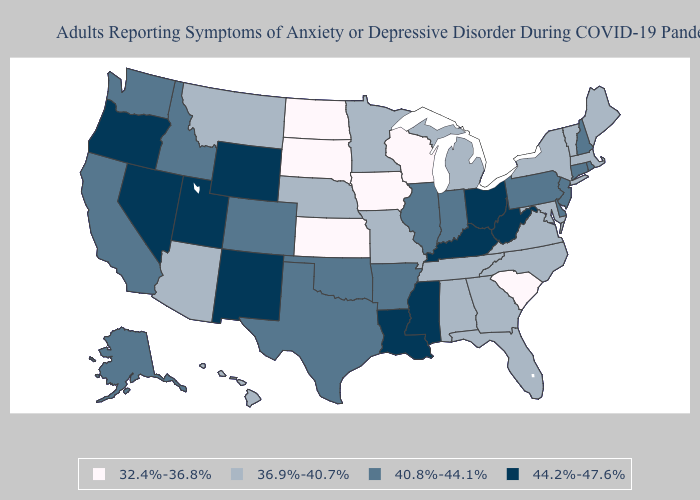What is the lowest value in the West?
Concise answer only. 36.9%-40.7%. Does Washington have the highest value in the West?
Be succinct. No. What is the highest value in the USA?
Quick response, please. 44.2%-47.6%. What is the lowest value in the Northeast?
Concise answer only. 36.9%-40.7%. Name the states that have a value in the range 40.8%-44.1%?
Keep it brief. Alaska, Arkansas, California, Colorado, Connecticut, Delaware, Idaho, Illinois, Indiana, New Hampshire, New Jersey, Oklahoma, Pennsylvania, Rhode Island, Texas, Washington. What is the value of Wyoming?
Concise answer only. 44.2%-47.6%. Does Montana have the lowest value in the West?
Keep it brief. Yes. What is the highest value in the Northeast ?
Write a very short answer. 40.8%-44.1%. Name the states that have a value in the range 32.4%-36.8%?
Answer briefly. Iowa, Kansas, North Dakota, South Carolina, South Dakota, Wisconsin. What is the value of Idaho?
Give a very brief answer. 40.8%-44.1%. Does Michigan have the highest value in the MidWest?
Write a very short answer. No. Does Tennessee have a lower value than Kentucky?
Quick response, please. Yes. Which states have the highest value in the USA?
Short answer required. Kentucky, Louisiana, Mississippi, Nevada, New Mexico, Ohio, Oregon, Utah, West Virginia, Wyoming. Does South Carolina have the lowest value in the USA?
Give a very brief answer. Yes. What is the lowest value in the Northeast?
Be succinct. 36.9%-40.7%. 